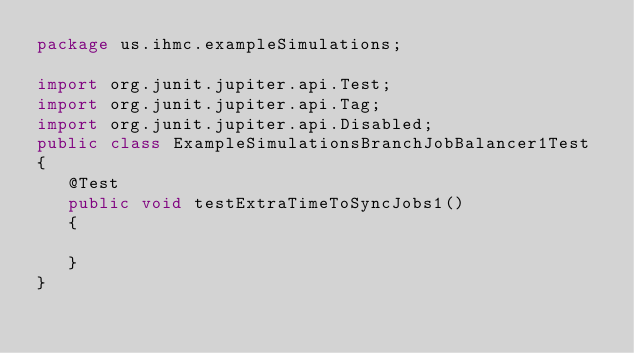Convert code to text. <code><loc_0><loc_0><loc_500><loc_500><_Java_>package us.ihmc.exampleSimulations;

import org.junit.jupiter.api.Test;
import org.junit.jupiter.api.Tag;
import org.junit.jupiter.api.Disabled;
public class ExampleSimulationsBranchJobBalancer1Test
{
   @Test
   public void testExtraTimeToSyncJobs1()
   {

   }
}
</code> 